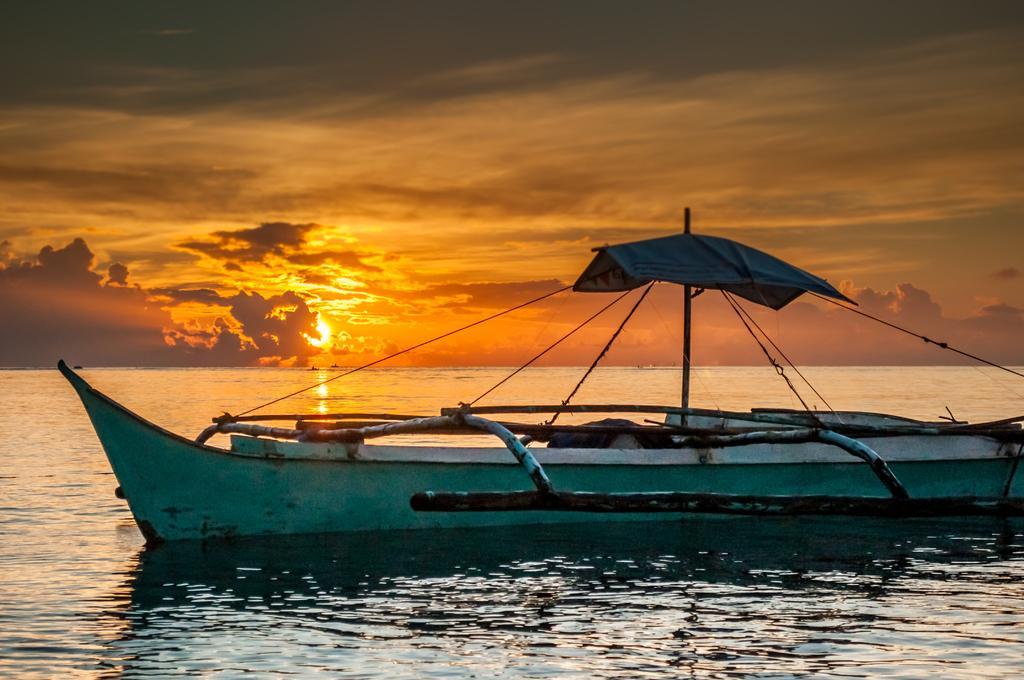Describe this image in one or two sentences. In this image we can see a boat in the water, sun and sky with clouds. 